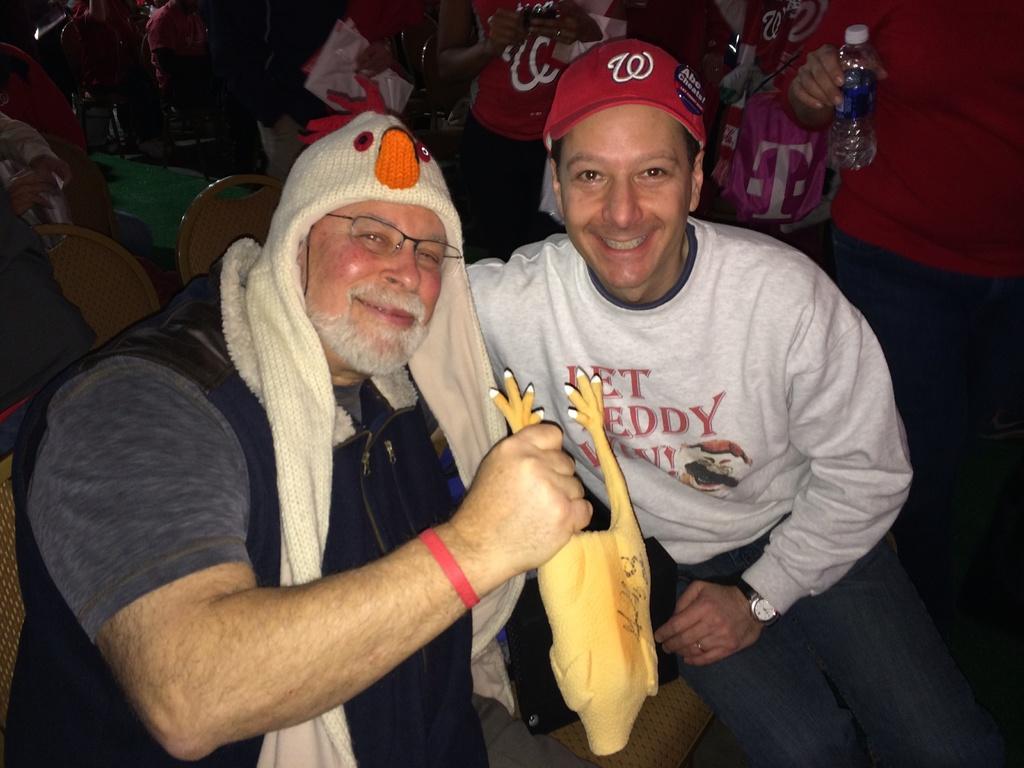What team is on the man's hat?
Offer a very short reply. W. What letter is in white on pink in the background?
Provide a succinct answer. T. 